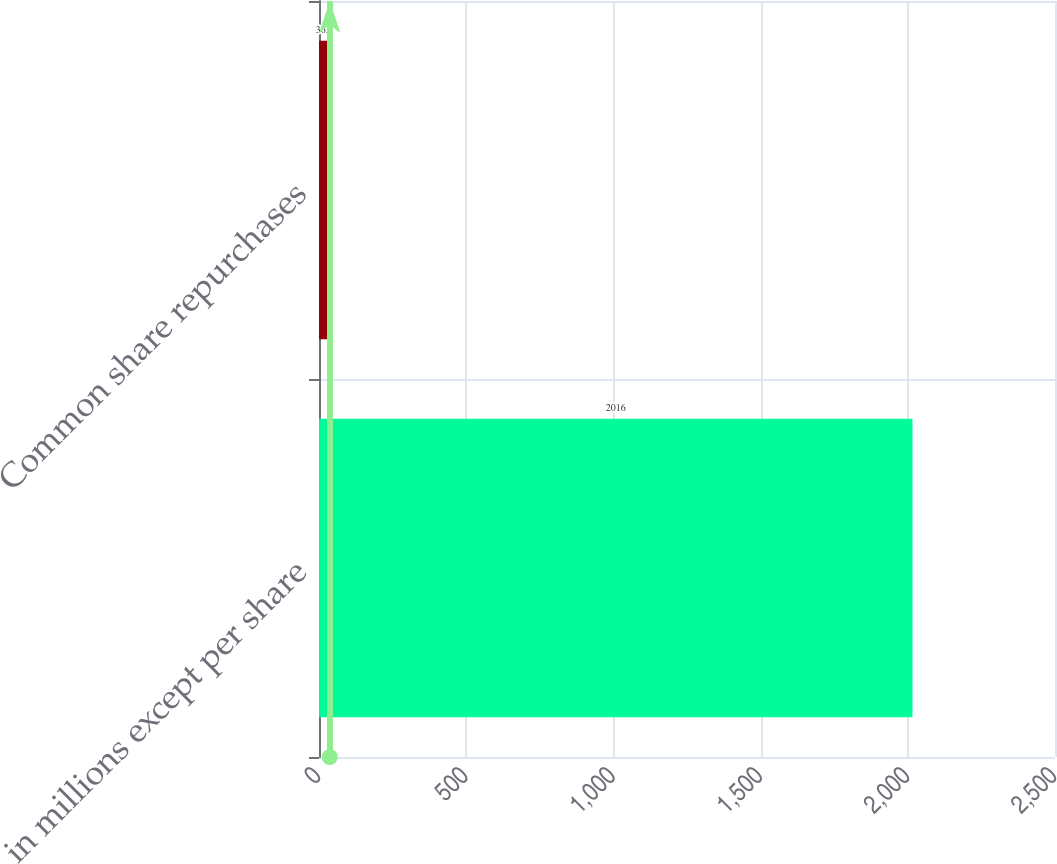Convert chart to OTSL. <chart><loc_0><loc_0><loc_500><loc_500><bar_chart><fcel>in millions except per share<fcel>Common share repurchases<nl><fcel>2016<fcel>36.6<nl></chart> 